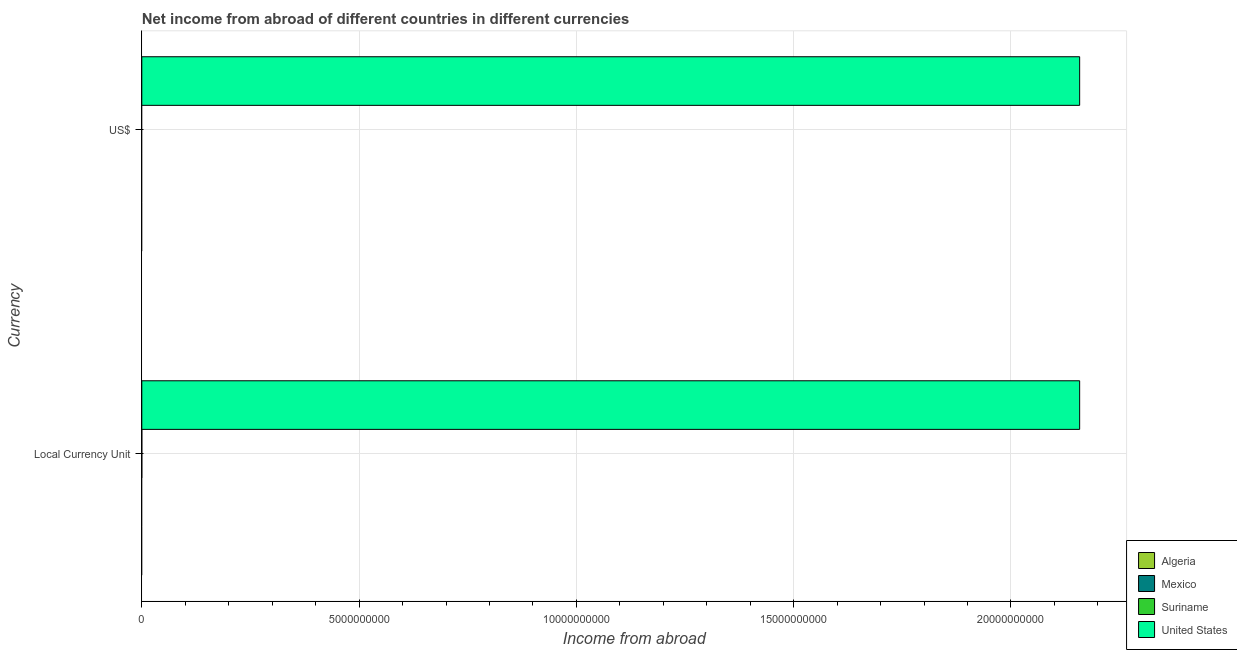What is the label of the 1st group of bars from the top?
Ensure brevity in your answer.  US$. Across all countries, what is the maximum income from abroad in constant 2005 us$?
Your answer should be compact. 2.16e+1. Across all countries, what is the minimum income from abroad in constant 2005 us$?
Ensure brevity in your answer.  0. In which country was the income from abroad in constant 2005 us$ maximum?
Give a very brief answer. United States. What is the total income from abroad in us$ in the graph?
Provide a succinct answer. 2.16e+1. What is the difference between the income from abroad in us$ in Algeria and the income from abroad in constant 2005 us$ in United States?
Provide a succinct answer. -2.16e+1. What is the average income from abroad in us$ per country?
Your answer should be compact. 5.40e+09. In how many countries, is the income from abroad in us$ greater than 7000000000 units?
Ensure brevity in your answer.  1. How many bars are there?
Your answer should be very brief. 2. What is the difference between two consecutive major ticks on the X-axis?
Give a very brief answer. 5.00e+09. Does the graph contain any zero values?
Provide a succinct answer. Yes. Does the graph contain grids?
Give a very brief answer. Yes. Where does the legend appear in the graph?
Offer a very short reply. Bottom right. How many legend labels are there?
Provide a short and direct response. 4. What is the title of the graph?
Keep it short and to the point. Net income from abroad of different countries in different currencies. What is the label or title of the X-axis?
Your response must be concise. Income from abroad. What is the label or title of the Y-axis?
Make the answer very short. Currency. What is the Income from abroad of Algeria in Local Currency Unit?
Offer a terse response. 0. What is the Income from abroad in Suriname in Local Currency Unit?
Provide a short and direct response. 0. What is the Income from abroad in United States in Local Currency Unit?
Ensure brevity in your answer.  2.16e+1. What is the Income from abroad of United States in US$?
Make the answer very short. 2.16e+1. Across all Currency, what is the maximum Income from abroad of United States?
Your answer should be very brief. 2.16e+1. Across all Currency, what is the minimum Income from abroad in United States?
Your answer should be compact. 2.16e+1. What is the total Income from abroad in United States in the graph?
Provide a short and direct response. 4.32e+1. What is the difference between the Income from abroad in United States in Local Currency Unit and that in US$?
Provide a succinct answer. 0. What is the average Income from abroad of Algeria per Currency?
Keep it short and to the point. 0. What is the average Income from abroad of Suriname per Currency?
Your response must be concise. 0. What is the average Income from abroad of United States per Currency?
Make the answer very short. 2.16e+1. What is the difference between the highest and the lowest Income from abroad in United States?
Offer a terse response. 0. 